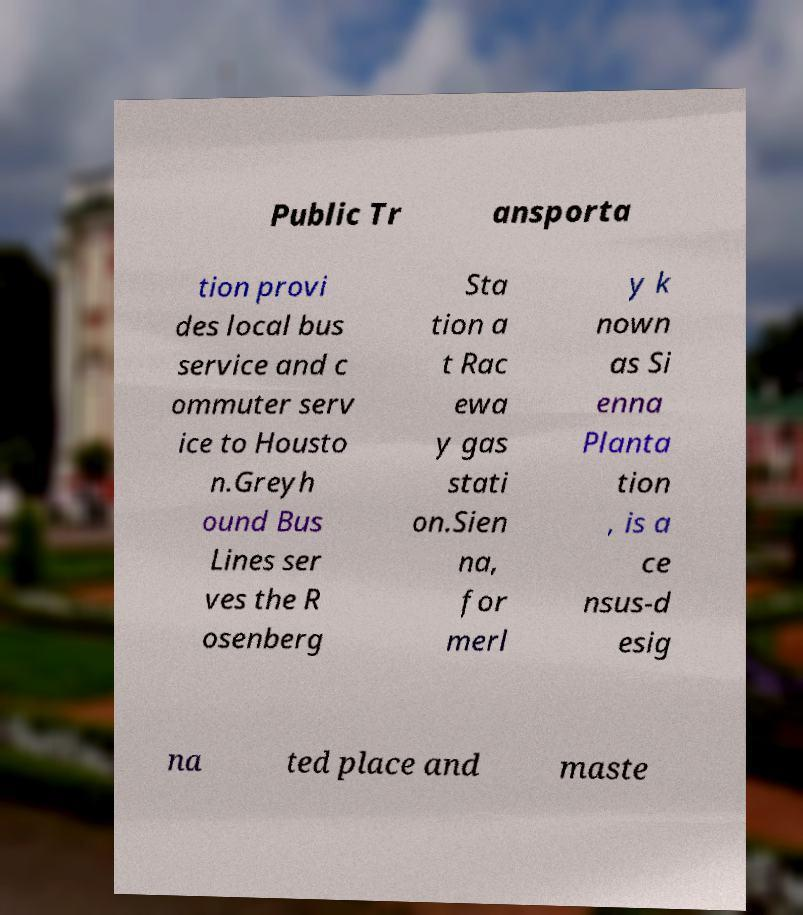Can you read and provide the text displayed in the image?This photo seems to have some interesting text. Can you extract and type it out for me? Public Tr ansporta tion provi des local bus service and c ommuter serv ice to Housto n.Greyh ound Bus Lines ser ves the R osenberg Sta tion a t Rac ewa y gas stati on.Sien na, for merl y k nown as Si enna Planta tion , is a ce nsus-d esig na ted place and maste 